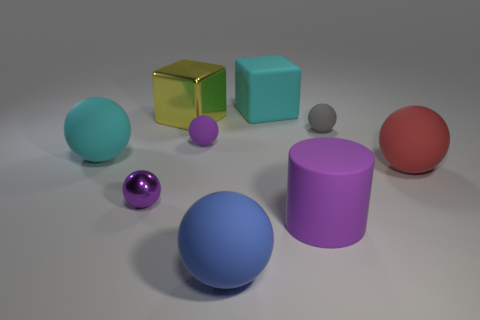Is there a purple ball made of the same material as the big purple object?
Ensure brevity in your answer.  Yes. What number of red shiny things are the same shape as the small gray matte thing?
Provide a short and direct response. 0. There is a large rubber object that is left of the tiny ball that is on the left side of the block in front of the big cyan rubber block; what shape is it?
Ensure brevity in your answer.  Sphere. There is a big object that is both behind the big matte cylinder and on the right side of the big cyan cube; what material is it?
Offer a very short reply. Rubber. Do the purple ball behind the red rubber ball and the big purple rubber cylinder have the same size?
Provide a short and direct response. No. Are there more large purple rubber cylinders that are left of the small purple shiny thing than big matte blocks that are on the right side of the big rubber cylinder?
Your answer should be compact. No. There is a small rubber sphere that is to the right of the large rubber sphere that is in front of the metallic thing in front of the gray matte ball; what color is it?
Keep it short and to the point. Gray. Is the color of the large matte thing that is in front of the big purple rubber thing the same as the big rubber cylinder?
Give a very brief answer. No. How many other things are the same color as the large cylinder?
Provide a succinct answer. 2. What number of things are blue metal cylinders or tiny gray things?
Ensure brevity in your answer.  1. 